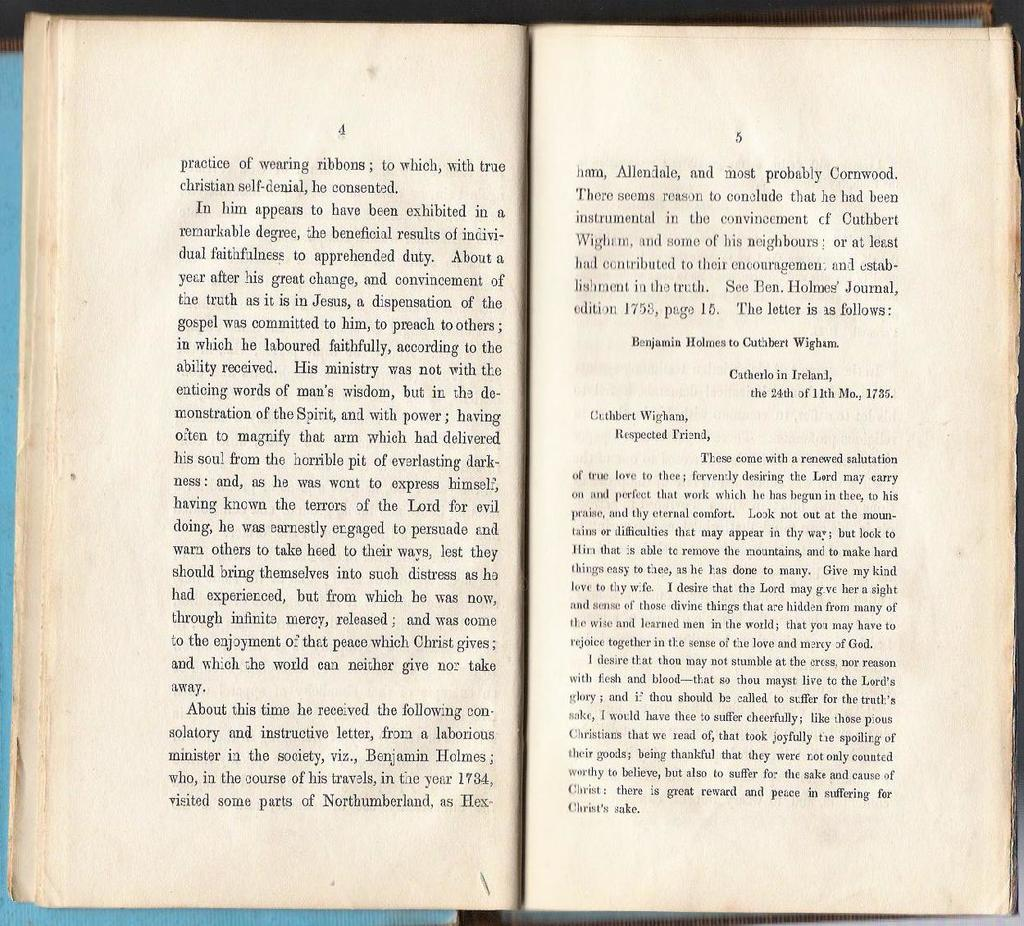<image>
Provide a brief description of the given image. A page from a book shows correspondence between people dating back to 1735. 